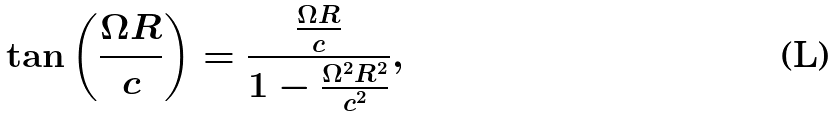Convert formula to latex. <formula><loc_0><loc_0><loc_500><loc_500>\tan \left ( \frac { \Omega R } { c } \right ) = \frac { \frac { \Omega R } { c } } { 1 - \frac { \Omega ^ { 2 } R ^ { 2 } } { c ^ { 2 } } } ,</formula> 